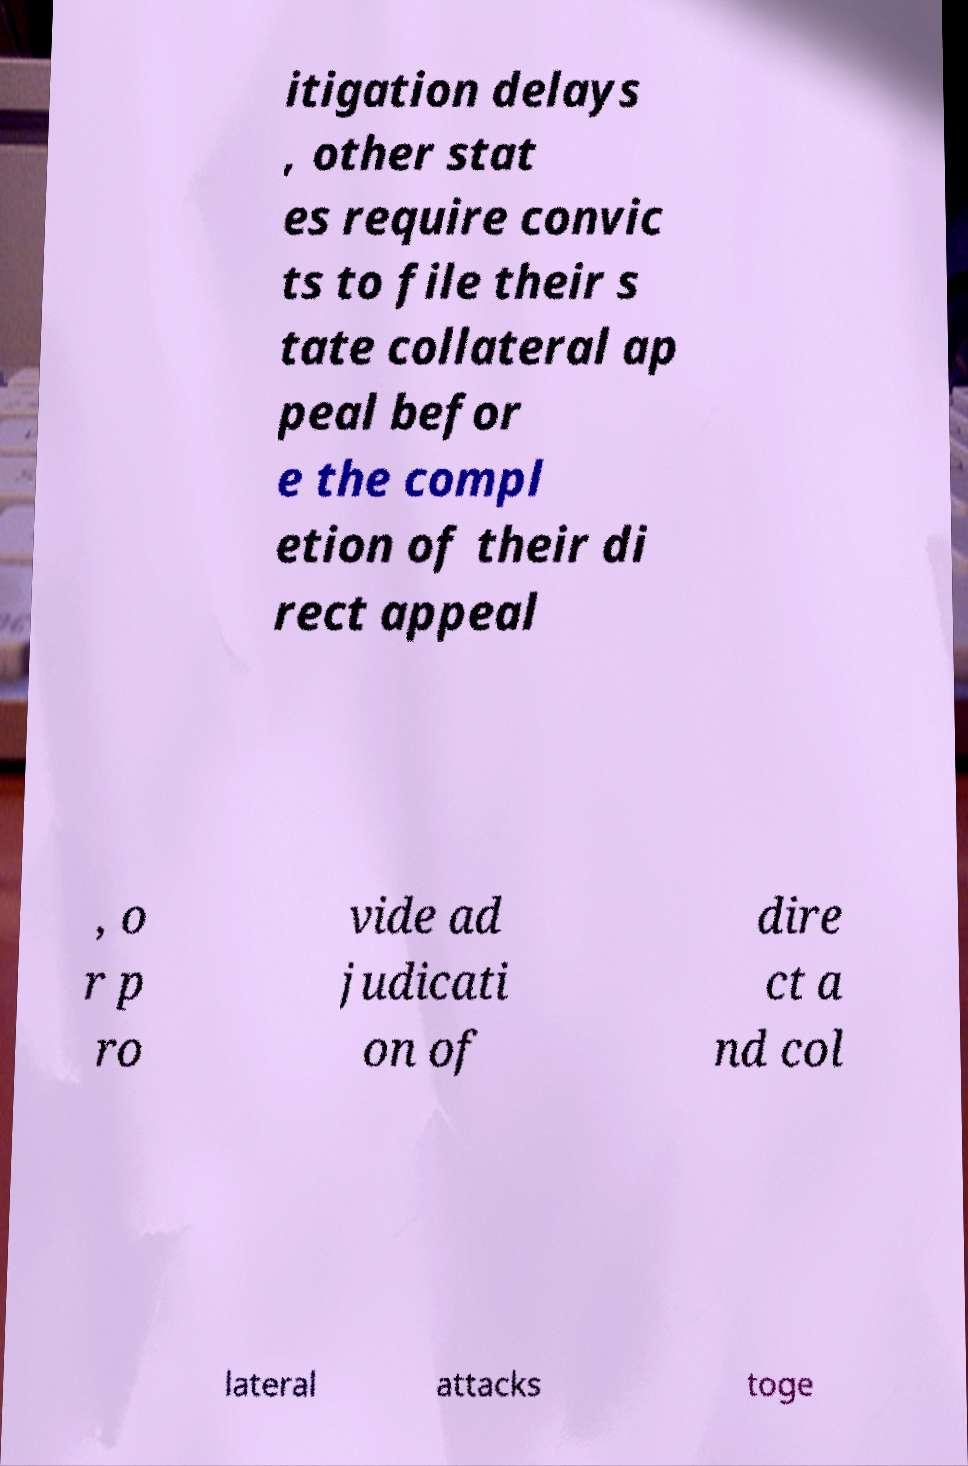What messages or text are displayed in this image? I need them in a readable, typed format. itigation delays , other stat es require convic ts to file their s tate collateral ap peal befor e the compl etion of their di rect appeal , o r p ro vide ad judicati on of dire ct a nd col lateral attacks toge 